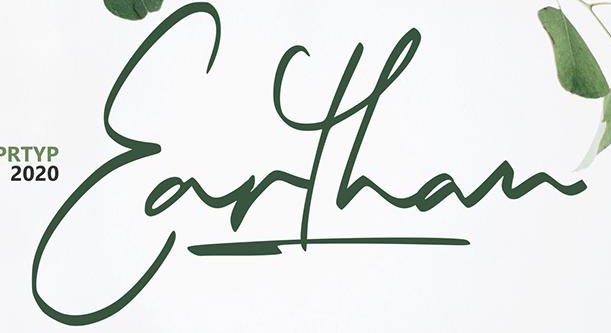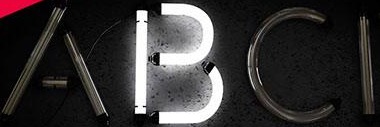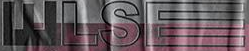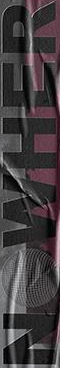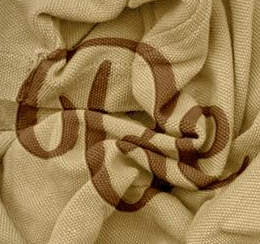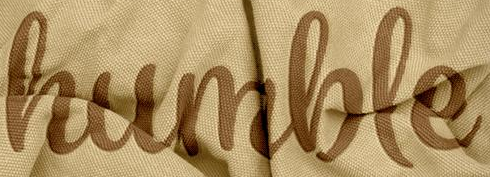Transcribe the words shown in these images in order, separated by a semicolon. Earthan; ABCI; WLSE; NOWHER; Be; humble 